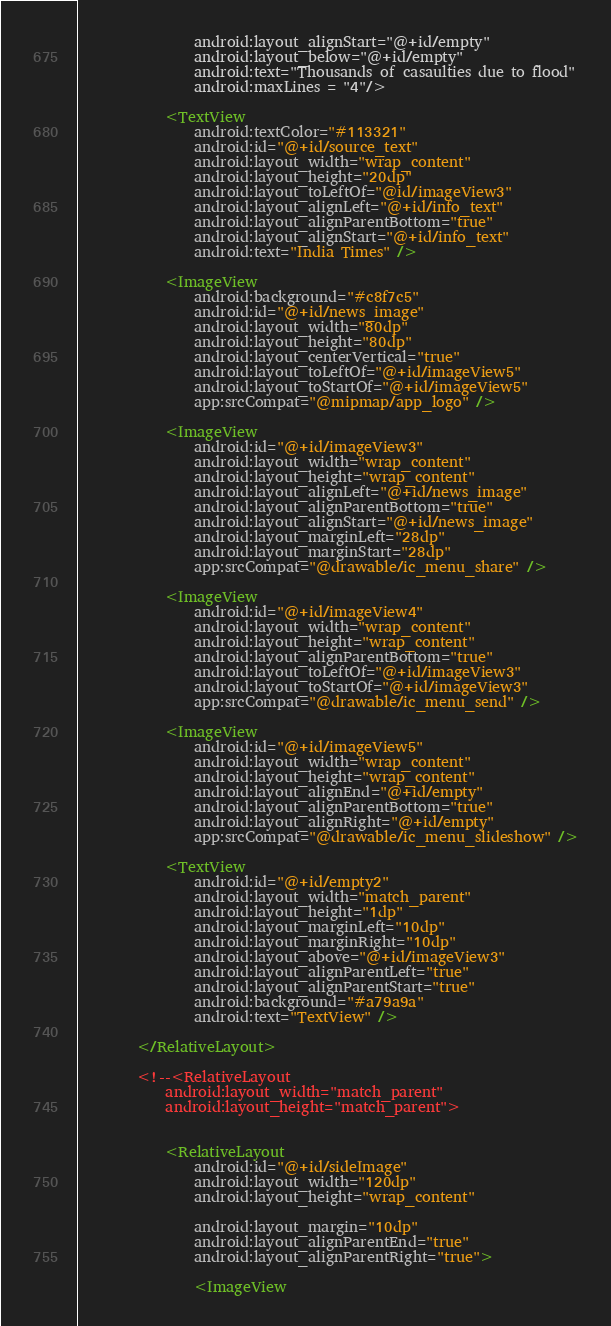Convert code to text. <code><loc_0><loc_0><loc_500><loc_500><_XML_>                android:layout_alignStart="@+id/empty"
                android:layout_below="@+id/empty"
                android:text="Thousands of casaulties due to flood"
                android:maxLines = "4"/>

            <TextView
                android:textColor="#113321"
                android:id="@+id/source_text"
                android:layout_width="wrap_content"
                android:layout_height="20dp"
                android:layout_toLeftOf="@id/imageView3"
                android:layout_alignLeft="@+id/info_text"
                android:layout_alignParentBottom="true"
                android:layout_alignStart="@+id/info_text"
                android:text="India Times" />

            <ImageView
                android:background="#c8f7c5"
                android:id="@+id/news_image"
                android:layout_width="80dp"
                android:layout_height="80dp"
                android:layout_centerVertical="true"
                android:layout_toLeftOf="@+id/imageView5"
                android:layout_toStartOf="@+id/imageView5"
                app:srcCompat="@mipmap/app_logo" />

            <ImageView
                android:id="@+id/imageView3"
                android:layout_width="wrap_content"
                android:layout_height="wrap_content"
                android:layout_alignLeft="@+id/news_image"
                android:layout_alignParentBottom="true"
                android:layout_alignStart="@+id/news_image"
                android:layout_marginLeft="28dp"
                android:layout_marginStart="28dp"
                app:srcCompat="@drawable/ic_menu_share" />

            <ImageView
                android:id="@+id/imageView4"
                android:layout_width="wrap_content"
                android:layout_height="wrap_content"
                android:layout_alignParentBottom="true"
                android:layout_toLeftOf="@+id/imageView3"
                android:layout_toStartOf="@+id/imageView3"
                app:srcCompat="@drawable/ic_menu_send" />

            <ImageView
                android:id="@+id/imageView5"
                android:layout_width="wrap_content"
                android:layout_height="wrap_content"
                android:layout_alignEnd="@+id/empty"
                android:layout_alignParentBottom="true"
                android:layout_alignRight="@+id/empty"
                app:srcCompat="@drawable/ic_menu_slideshow" />

            <TextView
                android:id="@+id/empty2"
                android:layout_width="match_parent"
                android:layout_height="1dp"
                android:layout_marginLeft="10dp"
                android:layout_marginRight="10dp"
                android:layout_above="@+id/imageView3"
                android:layout_alignParentLeft="true"
                android:layout_alignParentStart="true"
                android:background="#a79a9a"
                android:text="TextView" />

        </RelativeLayout>

        <!--<RelativeLayout
            android:layout_width="match_parent"
            android:layout_height="match_parent">


            <RelativeLayout
                android:id="@+id/sideImage"
                android:layout_width="120dp"
                android:layout_height="wrap_content"

                android:layout_margin="10dp"
                android:layout_alignParentEnd="true"
                android:layout_alignParentRight="true">

                <ImageView</code> 